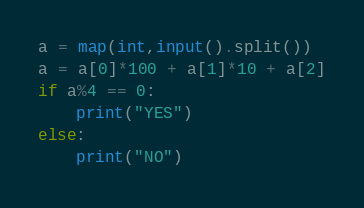Convert code to text. <code><loc_0><loc_0><loc_500><loc_500><_Python_>a = map(int,input().split())
a = a[0]*100 + a[1]*10 + a[2]
if a%4 == 0:
    print("YES")
else:
    print("NO")</code> 